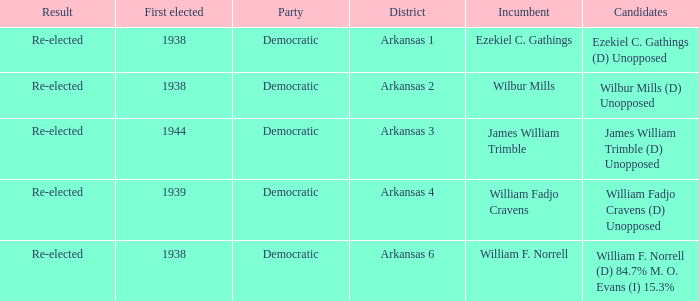Give me the full table as a dictionary. {'header': ['Result', 'First elected', 'Party', 'District', 'Incumbent', 'Candidates'], 'rows': [['Re-elected', '1938', 'Democratic', 'Arkansas 1', 'Ezekiel C. Gathings', 'Ezekiel C. Gathings (D) Unopposed'], ['Re-elected', '1938', 'Democratic', 'Arkansas 2', 'Wilbur Mills', 'Wilbur Mills (D) Unopposed'], ['Re-elected', '1944', 'Democratic', 'Arkansas 3', 'James William Trimble', 'James William Trimble (D) Unopposed'], ['Re-elected', '1939', 'Democratic', 'Arkansas 4', 'William Fadjo Cravens', 'William Fadjo Cravens (D) Unopposed'], ['Re-elected', '1938', 'Democratic', 'Arkansas 6', 'William F. Norrell', 'William F. Norrell (D) 84.7% M. O. Evans (I) 15.3%']]} How many were first elected in the Arkansas 4 district? 1.0. 